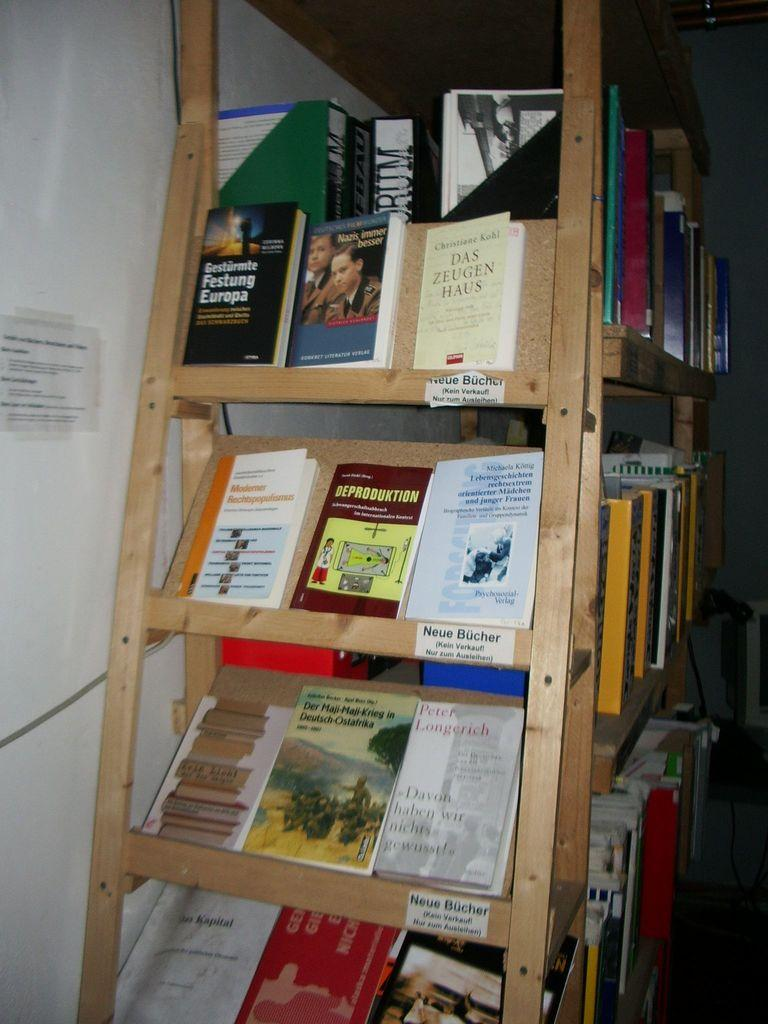<image>
Present a compact description of the photo's key features. A bookcase with books like Das Zeugen Haus on it. 